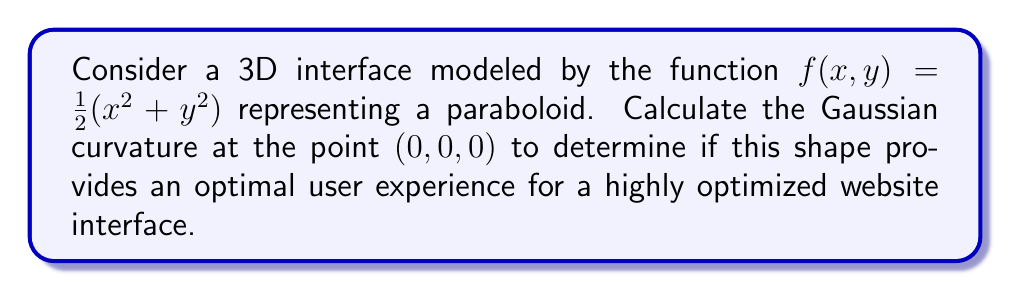Provide a solution to this math problem. To find the Gaussian curvature, we need to follow these steps:

1) First, we need to calculate the first and second partial derivatives of $f(x,y)$:

   $f_x = x$
   $f_y = y$
   $f_{xx} = 1$
   $f_{yy} = 1$
   $f_{xy} = 0$

2) Next, we need to calculate the coefficients of the first fundamental form:

   $E = 1 + f_x^2 = 1 + x^2$
   $F = f_x f_y = xy$
   $G = 1 + f_y^2 = 1 + y^2$

3) Then, we calculate the coefficients of the second fundamental form:

   $L = \frac{f_{xx}}{\sqrt{1 + f_x^2 + f_y^2}} = \frac{1}{\sqrt{1 + x^2 + y^2}}$
   $M = \frac{f_{xy}}{\sqrt{1 + f_x^2 + f_y^2}} = 0$
   $N = \frac{f_{yy}}{\sqrt{1 + f_x^2 + f_y^2}} = \frac{1}{\sqrt{1 + x^2 + y^2}}$

4) The Gaussian curvature is given by the formula:

   $K = \frac{LN - M^2}{EG - F^2}$

5) Substituting the values at the point $(0,0,0)$:

   $K = \frac{(1)(1) - 0^2}{(1)(1) - 0^2} = 1$

Therefore, the Gaussian curvature at $(0,0,0)$ is 1.

For a user interface, a positive Gaussian curvature indicates a dome-like shape, which can be beneficial for creating a focal point and guiding user attention. However, a curvature of 1 is relatively high and might be too steep for optimal user experience. A gentler curve (lower positive curvature) might provide a more comfortable viewing experience while still maintaining the benefits of a curved interface.
Answer: $K = 1$ 